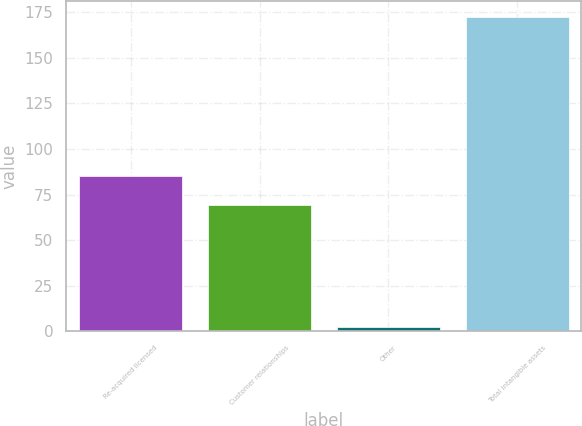Convert chart. <chart><loc_0><loc_0><loc_500><loc_500><bar_chart><fcel>Re-acquired licensed<fcel>Customer relationships<fcel>Other<fcel>Total intangible assets<nl><fcel>85.3<fcel>69.2<fcel>2.7<fcel>172.5<nl></chart> 